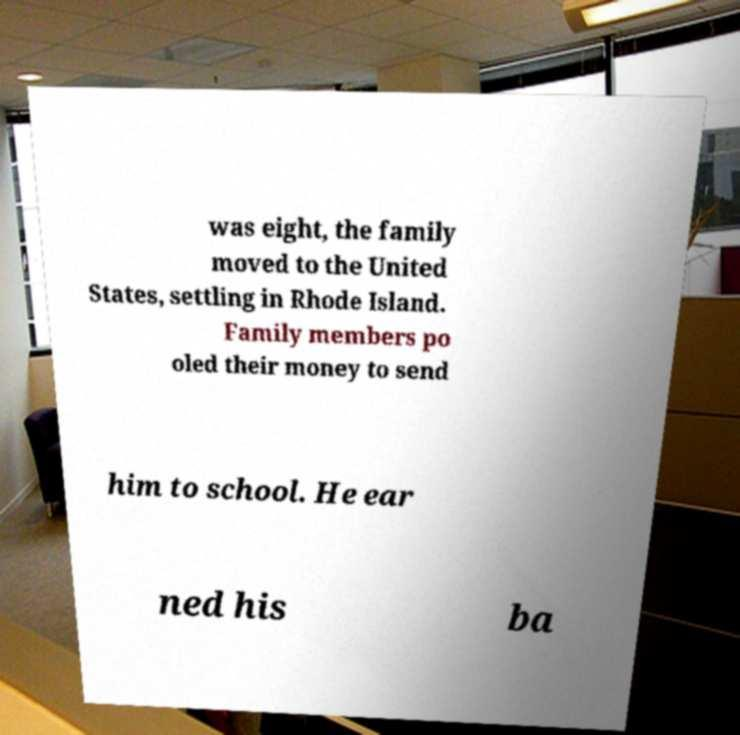Please read and relay the text visible in this image. What does it say? was eight, the family moved to the United States, settling in Rhode Island. Family members po oled their money to send him to school. He ear ned his ba 